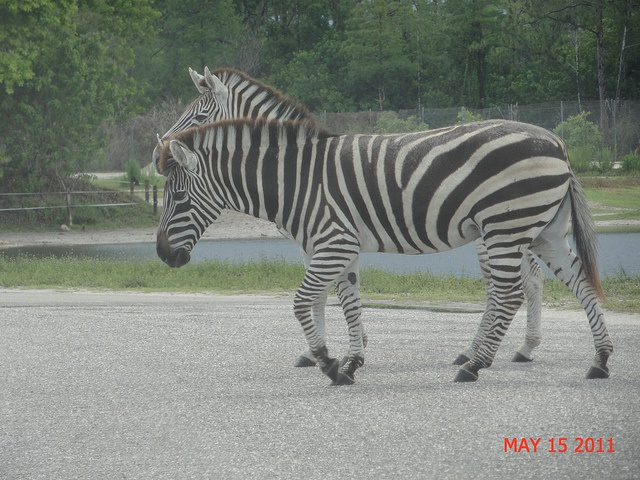Describe the objects in this image and their specific colors. I can see zebra in darkgreen, gray, darkgray, and black tones and zebra in darkgreen, darkgray, and gray tones in this image. 